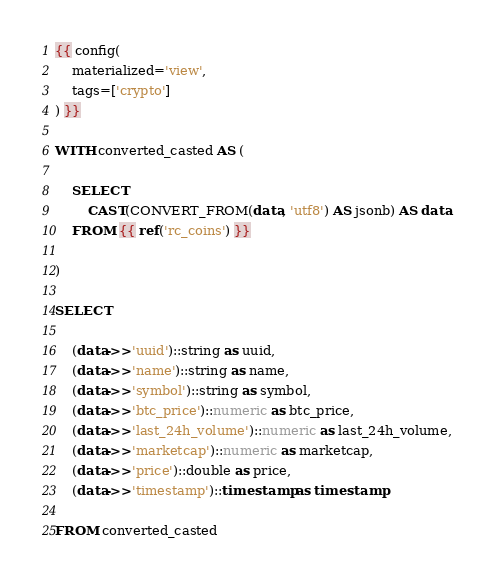<code> <loc_0><loc_0><loc_500><loc_500><_SQL_>{{ config(
    materialized='view',
    tags=['crypto']
) }}

WITH converted_casted AS (
    
    SELECT 
        CAST(CONVERT_FROM(data, 'utf8') AS jsonb) AS data
    FROM {{ ref('rc_coins') }}

)

SELECT

    (data->>'uuid')::string as uuid,
    (data->>'name')::string as name,
    (data->>'symbol')::string as symbol,
    (data->>'btc_price')::numeric as btc_price,
    (data->>'last_24h_volume')::numeric as last_24h_volume,
    (data->>'marketcap')::numeric as marketcap,
    (data->>'price')::double as price,
    (data->>'timestamp')::timestamp as timestamp

FROM converted_casted
</code> 